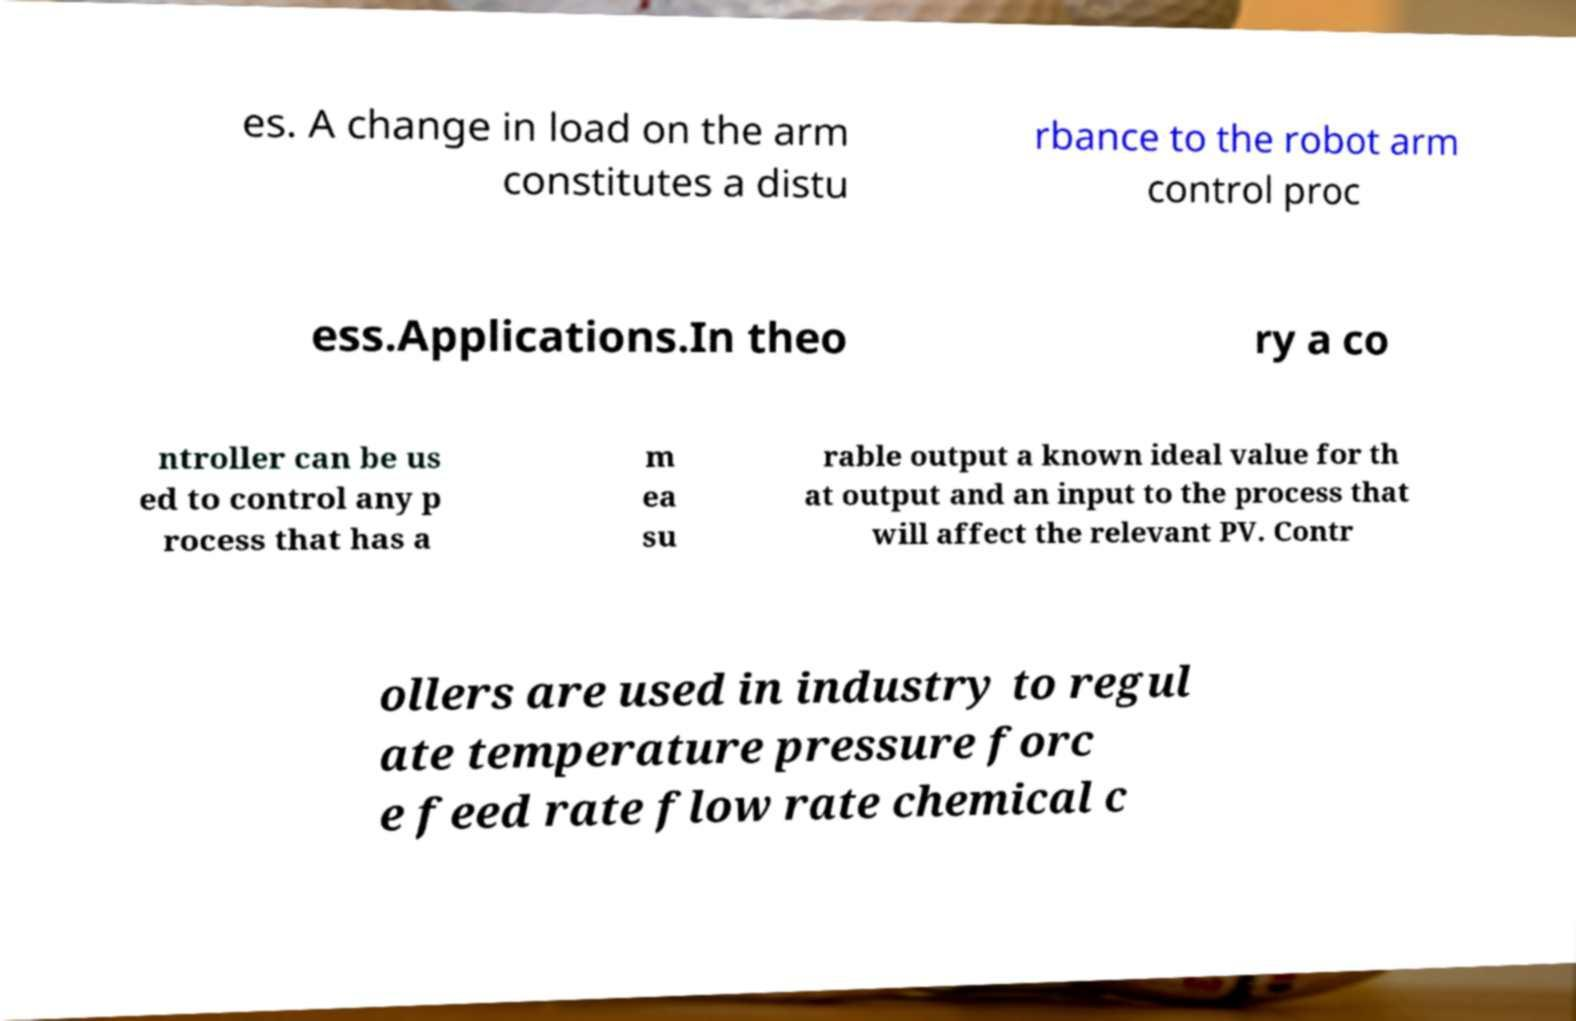Please read and relay the text visible in this image. What does it say? es. A change in load on the arm constitutes a distu rbance to the robot arm control proc ess.Applications.In theo ry a co ntroller can be us ed to control any p rocess that has a m ea su rable output a known ideal value for th at output and an input to the process that will affect the relevant PV. Contr ollers are used in industry to regul ate temperature pressure forc e feed rate flow rate chemical c 